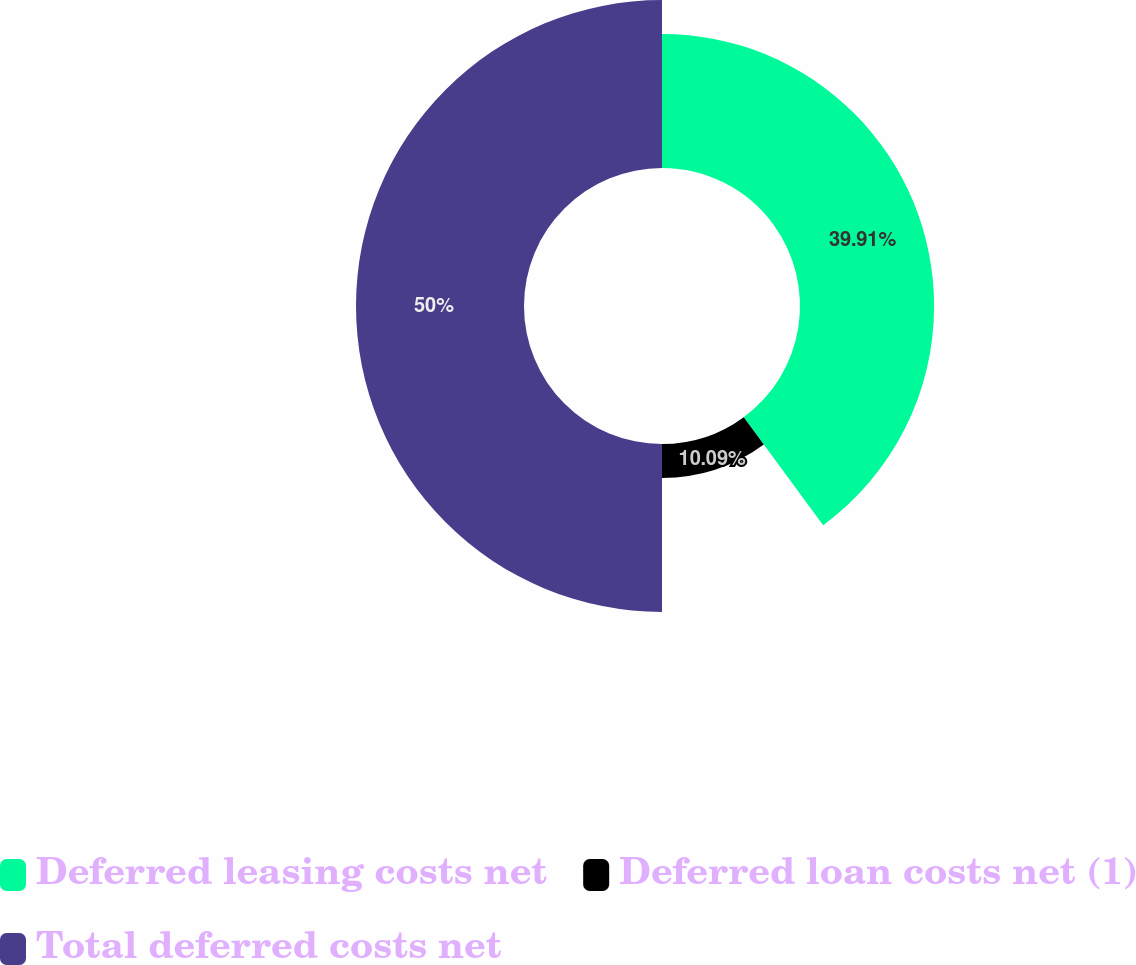Convert chart. <chart><loc_0><loc_0><loc_500><loc_500><pie_chart><fcel>Deferred leasing costs net<fcel>Deferred loan costs net (1)<fcel>Total deferred costs net<nl><fcel>39.91%<fcel>10.09%<fcel>50.0%<nl></chart> 